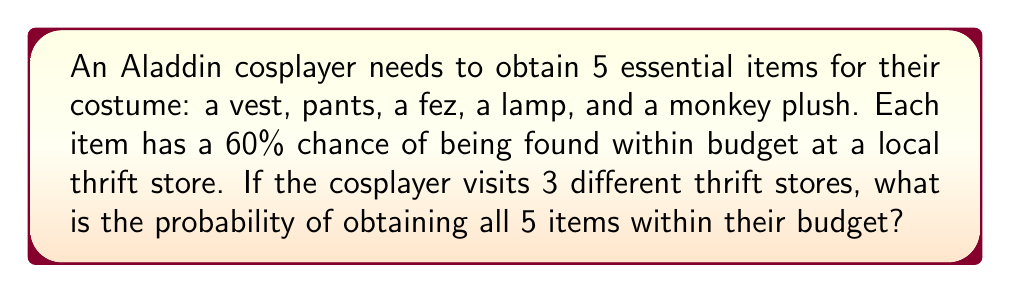Teach me how to tackle this problem. Let's approach this step-by-step:

1) For each item, the probability of not finding it at a single store is 40% or 0.4.

2) The probability of not finding an item after visiting 3 stores is:
   $$(0.4)^3 = 0.064$$

3) Therefore, the probability of finding an item after visiting 3 stores is:
   $$1 - (0.4)^3 = 0.936$$

4) We need all 5 items, so we multiply the probabilities:
   $$(0.936)^5 = 0.7248$$

5) Convert to a percentage:
   $$0.7248 \times 100\% = 72.48\%$$

This calculation assumes independence between finding different items and between visits to different stores.
Answer: 72.48% 